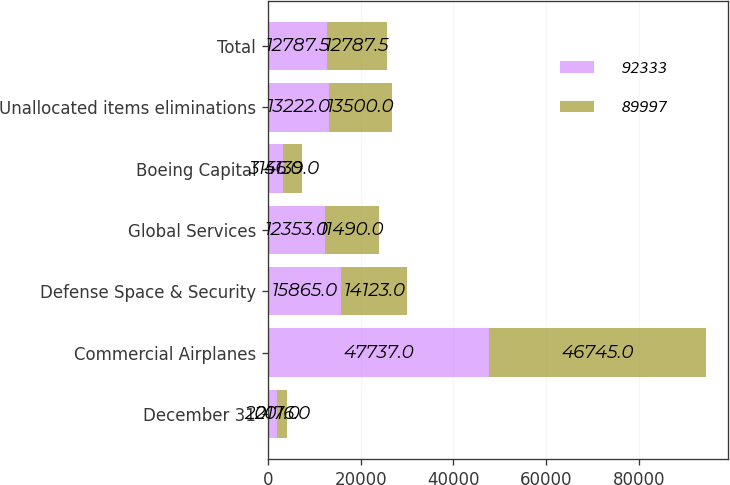Convert chart to OTSL. <chart><loc_0><loc_0><loc_500><loc_500><stacked_bar_chart><ecel><fcel>December 31<fcel>Commercial Airplanes<fcel>Defense Space & Security<fcel>Global Services<fcel>Boeing Capital<fcel>Unallocated items eliminations<fcel>Total<nl><fcel>92333<fcel>2017<fcel>47737<fcel>15865<fcel>12353<fcel>3156<fcel>13222<fcel>12787.5<nl><fcel>89997<fcel>2016<fcel>46745<fcel>14123<fcel>11490<fcel>4139<fcel>13500<fcel>12787.5<nl></chart> 